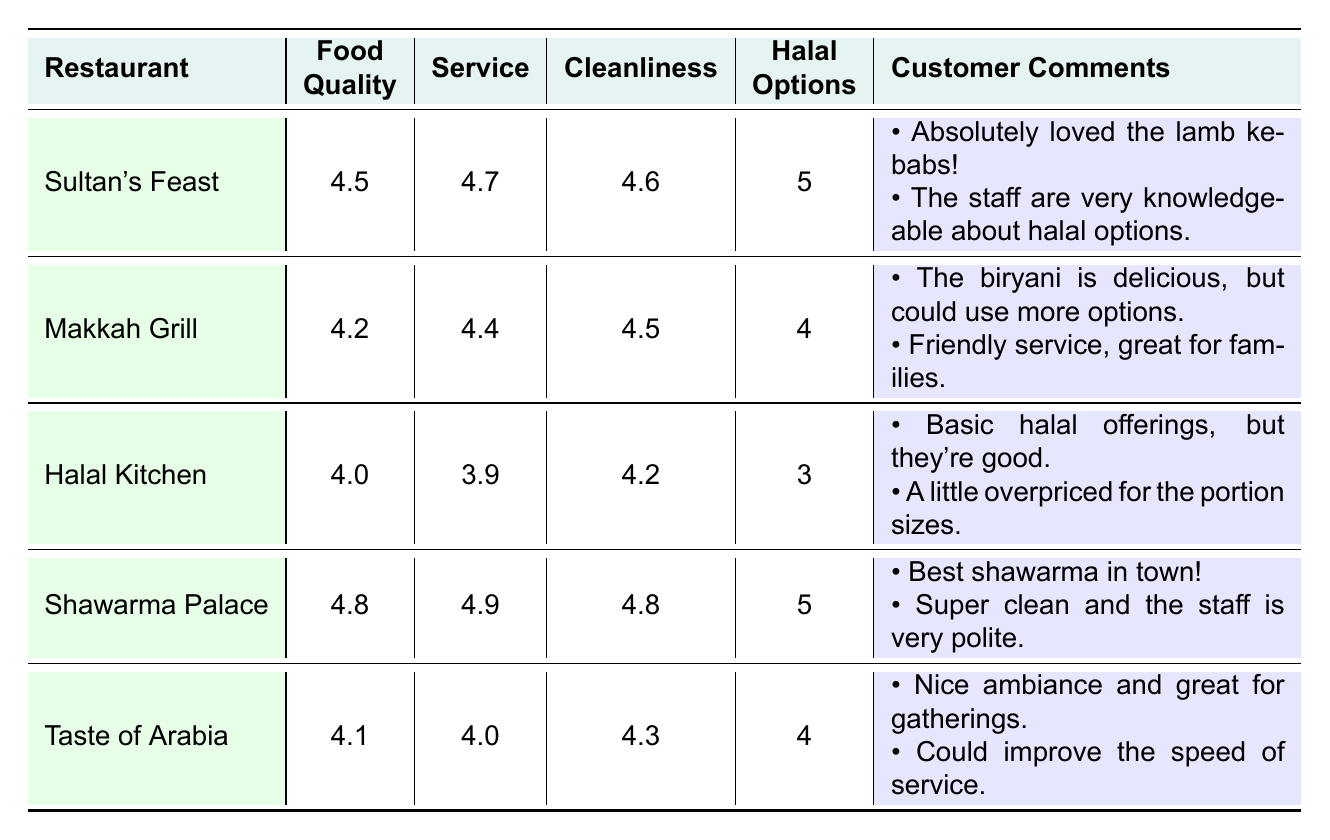What is the highest food quality rating among the restaurants? The highest food quality rating is found by comparing the food quality ratings of all restaurants. The highest rating is 4.8, which belongs to Shawarma Palace.
Answer: 4.8 Which restaurant has the best service rating? The best service rating is determined by looking at the service ratings of all the restaurants. Shawarma Palace has the highest service rating of 4.9.
Answer: 4.9 Do all restaurants have at least 4 halal options? Checking the variety of halal options for each restaurant shows that Halal Kitchen has only 3 halal options. Therefore, not all restaurants have at least 4 halal options.
Answer: No What is the average cleanliness rating of the restaurants? To find the average cleanliness rating, we add the cleanliness ratings: (4.6 + 4.5 + 4.2 + 4.8 + 4.3) = 22.4. Then, we divide by the number of restaurants (5), resulting in an average cleanliness rating of 4.48.
Answer: 4.48 Is there a restaurant with five halal options that also has a food quality rating above 4.5? By examining the table, both Sultan's Feast and Shawarma Palace have 5 halal options. Checking their food quality ratings, Sultan's Feast has 4.5 and Shawarma Palace has 4.8, confirming that both meet the criteria.
Answer: Yes Which restaurant had the comment about being "basic halal offerings"? The comment about "basic halal offerings, but they're good" is from Halal Kitchen.
Answer: Halal Kitchen What is the difference in food quality ratings between the highest and lowest rated restaurants? The highest food quality rating is 4.8 (Shawarma Palace) and the lowest is 4.0 (Halal Kitchen). The difference is calculated by subtracting the lowest from the highest: 4.8 - 4.0 = 0.8.
Answer: 0.8 How many restaurants had cleanliness ratings of 4.5 or higher? By checking the cleanliness ratings, Sultan's Feast, Makkah Grill, Shawarma Palace, and Taste of Arabia had ratings of 4.5 or higher. Counting these gives a total of 4 restaurants.
Answer: 4 Which restaurant received the most positive customer comments? No numeric method is applicable here but by reviewing the customer comments, both Sultan's Feast and Shawarma Palace had two very positive comments, highlighting satisfaction. Therefore, they both received an equal amount of positive feedback.
Answer: Sultan's Feast and Shawarma Palace 